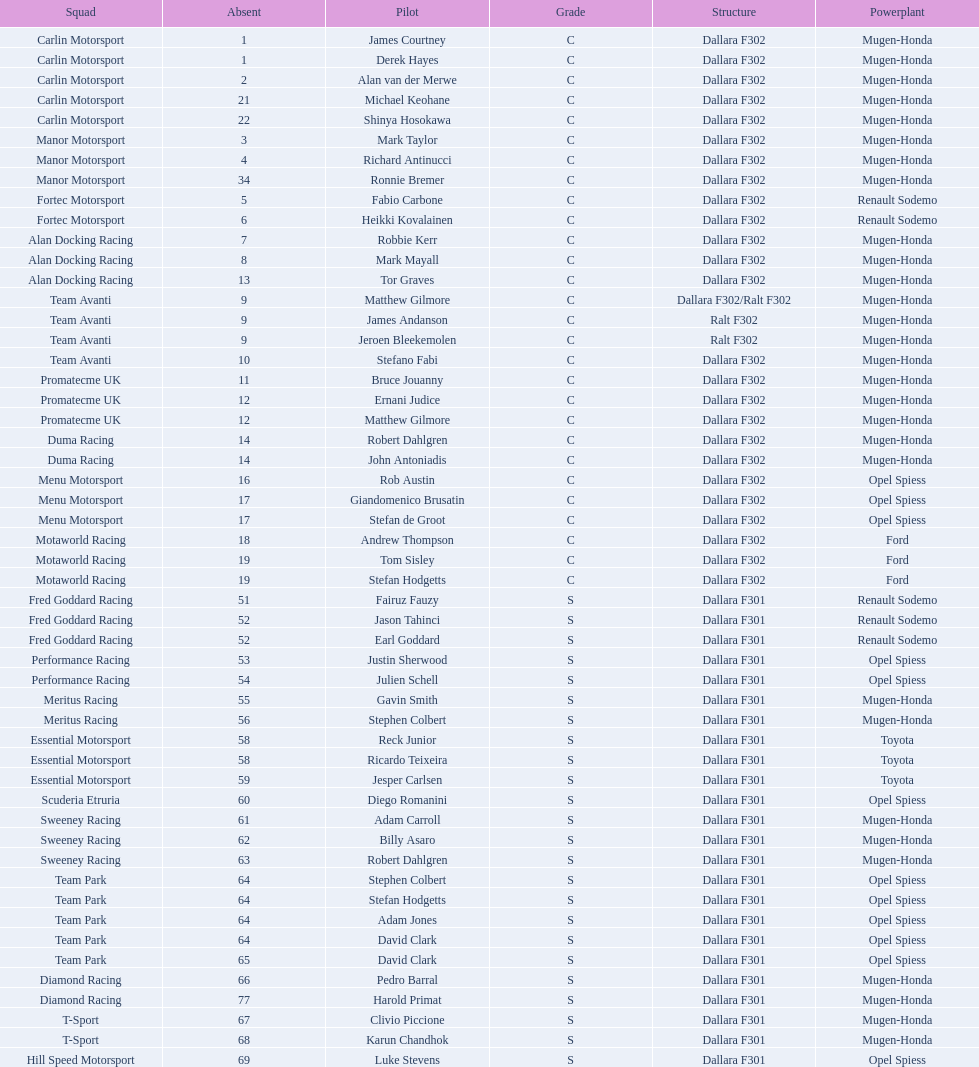How many class s (scholarship) teams are on the chart? 19. 